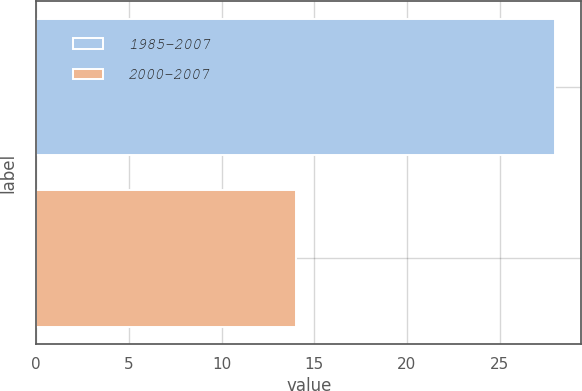<chart> <loc_0><loc_0><loc_500><loc_500><bar_chart><fcel>1985-2007<fcel>2000-2007<nl><fcel>28<fcel>14<nl></chart> 